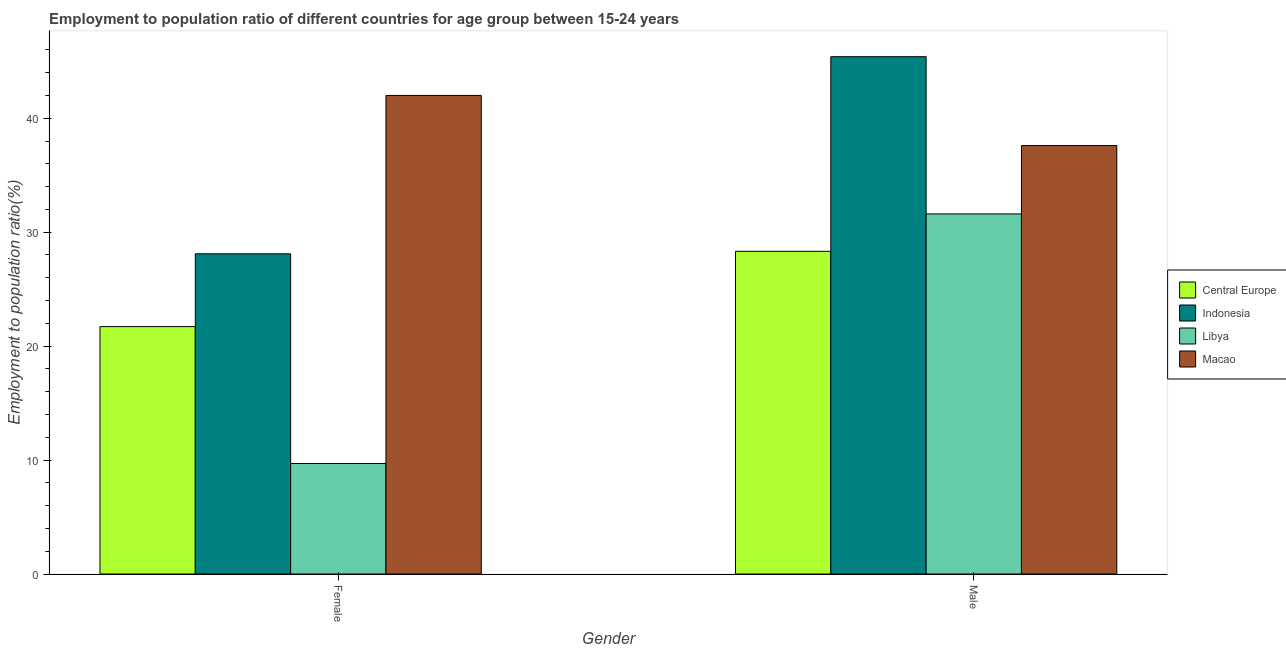How many bars are there on the 2nd tick from the left?
Provide a short and direct response. 4. How many bars are there on the 2nd tick from the right?
Ensure brevity in your answer.  4. What is the label of the 1st group of bars from the left?
Offer a terse response. Female. What is the employment to population ratio(female) in Libya?
Offer a very short reply. 9.7. Across all countries, what is the maximum employment to population ratio(male)?
Make the answer very short. 45.4. Across all countries, what is the minimum employment to population ratio(female)?
Provide a succinct answer. 9.7. In which country was the employment to population ratio(male) minimum?
Provide a succinct answer. Central Europe. What is the total employment to population ratio(female) in the graph?
Make the answer very short. 101.51. What is the difference between the employment to population ratio(female) in Central Europe and that in Libya?
Your answer should be compact. 12.01. What is the difference between the employment to population ratio(male) in Central Europe and the employment to population ratio(female) in Indonesia?
Offer a terse response. 0.22. What is the average employment to population ratio(male) per country?
Ensure brevity in your answer.  35.73. What is the difference between the employment to population ratio(male) and employment to population ratio(female) in Central Europe?
Provide a short and direct response. 6.61. What is the ratio of the employment to population ratio(female) in Indonesia to that in Central Europe?
Keep it short and to the point. 1.29. In how many countries, is the employment to population ratio(female) greater than the average employment to population ratio(female) taken over all countries?
Provide a succinct answer. 2. What does the 2nd bar from the left in Male represents?
Your answer should be compact. Indonesia. What does the 1st bar from the right in Male represents?
Offer a terse response. Macao. What is the difference between two consecutive major ticks on the Y-axis?
Make the answer very short. 10. Does the graph contain any zero values?
Make the answer very short. No. Where does the legend appear in the graph?
Your answer should be compact. Center right. How many legend labels are there?
Your answer should be compact. 4. How are the legend labels stacked?
Your response must be concise. Vertical. What is the title of the graph?
Your response must be concise. Employment to population ratio of different countries for age group between 15-24 years. Does "Liechtenstein" appear as one of the legend labels in the graph?
Ensure brevity in your answer.  No. What is the label or title of the X-axis?
Make the answer very short. Gender. What is the label or title of the Y-axis?
Offer a very short reply. Employment to population ratio(%). What is the Employment to population ratio(%) in Central Europe in Female?
Make the answer very short. 21.71. What is the Employment to population ratio(%) in Indonesia in Female?
Offer a very short reply. 28.1. What is the Employment to population ratio(%) of Libya in Female?
Your response must be concise. 9.7. What is the Employment to population ratio(%) in Central Europe in Male?
Give a very brief answer. 28.32. What is the Employment to population ratio(%) in Indonesia in Male?
Make the answer very short. 45.4. What is the Employment to population ratio(%) in Libya in Male?
Make the answer very short. 31.6. What is the Employment to population ratio(%) in Macao in Male?
Your answer should be very brief. 37.6. Across all Gender, what is the maximum Employment to population ratio(%) in Central Europe?
Offer a terse response. 28.32. Across all Gender, what is the maximum Employment to population ratio(%) of Indonesia?
Give a very brief answer. 45.4. Across all Gender, what is the maximum Employment to population ratio(%) of Libya?
Your answer should be compact. 31.6. Across all Gender, what is the minimum Employment to population ratio(%) in Central Europe?
Make the answer very short. 21.71. Across all Gender, what is the minimum Employment to population ratio(%) in Indonesia?
Your answer should be very brief. 28.1. Across all Gender, what is the minimum Employment to population ratio(%) of Libya?
Ensure brevity in your answer.  9.7. Across all Gender, what is the minimum Employment to population ratio(%) in Macao?
Give a very brief answer. 37.6. What is the total Employment to population ratio(%) of Central Europe in the graph?
Make the answer very short. 50.03. What is the total Employment to population ratio(%) in Indonesia in the graph?
Keep it short and to the point. 73.5. What is the total Employment to population ratio(%) of Libya in the graph?
Provide a short and direct response. 41.3. What is the total Employment to population ratio(%) of Macao in the graph?
Your response must be concise. 79.6. What is the difference between the Employment to population ratio(%) of Central Europe in Female and that in Male?
Your answer should be compact. -6.61. What is the difference between the Employment to population ratio(%) of Indonesia in Female and that in Male?
Keep it short and to the point. -17.3. What is the difference between the Employment to population ratio(%) of Libya in Female and that in Male?
Ensure brevity in your answer.  -21.9. What is the difference between the Employment to population ratio(%) of Central Europe in Female and the Employment to population ratio(%) of Indonesia in Male?
Offer a very short reply. -23.69. What is the difference between the Employment to population ratio(%) in Central Europe in Female and the Employment to population ratio(%) in Libya in Male?
Offer a very short reply. -9.89. What is the difference between the Employment to population ratio(%) in Central Europe in Female and the Employment to population ratio(%) in Macao in Male?
Your answer should be compact. -15.89. What is the difference between the Employment to population ratio(%) of Indonesia in Female and the Employment to population ratio(%) of Libya in Male?
Keep it short and to the point. -3.5. What is the difference between the Employment to population ratio(%) of Indonesia in Female and the Employment to population ratio(%) of Macao in Male?
Your answer should be very brief. -9.5. What is the difference between the Employment to population ratio(%) in Libya in Female and the Employment to population ratio(%) in Macao in Male?
Provide a succinct answer. -27.9. What is the average Employment to population ratio(%) of Central Europe per Gender?
Your answer should be compact. 25.02. What is the average Employment to population ratio(%) of Indonesia per Gender?
Make the answer very short. 36.75. What is the average Employment to population ratio(%) in Libya per Gender?
Keep it short and to the point. 20.65. What is the average Employment to population ratio(%) of Macao per Gender?
Provide a short and direct response. 39.8. What is the difference between the Employment to population ratio(%) of Central Europe and Employment to population ratio(%) of Indonesia in Female?
Your answer should be very brief. -6.39. What is the difference between the Employment to population ratio(%) of Central Europe and Employment to population ratio(%) of Libya in Female?
Your answer should be compact. 12.01. What is the difference between the Employment to population ratio(%) of Central Europe and Employment to population ratio(%) of Macao in Female?
Ensure brevity in your answer.  -20.29. What is the difference between the Employment to population ratio(%) in Indonesia and Employment to population ratio(%) in Libya in Female?
Keep it short and to the point. 18.4. What is the difference between the Employment to population ratio(%) in Indonesia and Employment to population ratio(%) in Macao in Female?
Give a very brief answer. -13.9. What is the difference between the Employment to population ratio(%) of Libya and Employment to population ratio(%) of Macao in Female?
Your response must be concise. -32.3. What is the difference between the Employment to population ratio(%) in Central Europe and Employment to population ratio(%) in Indonesia in Male?
Make the answer very short. -17.08. What is the difference between the Employment to population ratio(%) of Central Europe and Employment to population ratio(%) of Libya in Male?
Your answer should be compact. -3.28. What is the difference between the Employment to population ratio(%) in Central Europe and Employment to population ratio(%) in Macao in Male?
Ensure brevity in your answer.  -9.28. What is the difference between the Employment to population ratio(%) of Libya and Employment to population ratio(%) of Macao in Male?
Ensure brevity in your answer.  -6. What is the ratio of the Employment to population ratio(%) of Central Europe in Female to that in Male?
Your answer should be compact. 0.77. What is the ratio of the Employment to population ratio(%) of Indonesia in Female to that in Male?
Provide a short and direct response. 0.62. What is the ratio of the Employment to population ratio(%) of Libya in Female to that in Male?
Make the answer very short. 0.31. What is the ratio of the Employment to population ratio(%) in Macao in Female to that in Male?
Your answer should be compact. 1.12. What is the difference between the highest and the second highest Employment to population ratio(%) of Central Europe?
Provide a short and direct response. 6.61. What is the difference between the highest and the second highest Employment to population ratio(%) in Indonesia?
Make the answer very short. 17.3. What is the difference between the highest and the second highest Employment to population ratio(%) in Libya?
Make the answer very short. 21.9. What is the difference between the highest and the lowest Employment to population ratio(%) in Central Europe?
Your answer should be compact. 6.61. What is the difference between the highest and the lowest Employment to population ratio(%) in Indonesia?
Your response must be concise. 17.3. What is the difference between the highest and the lowest Employment to population ratio(%) in Libya?
Make the answer very short. 21.9. What is the difference between the highest and the lowest Employment to population ratio(%) in Macao?
Provide a short and direct response. 4.4. 